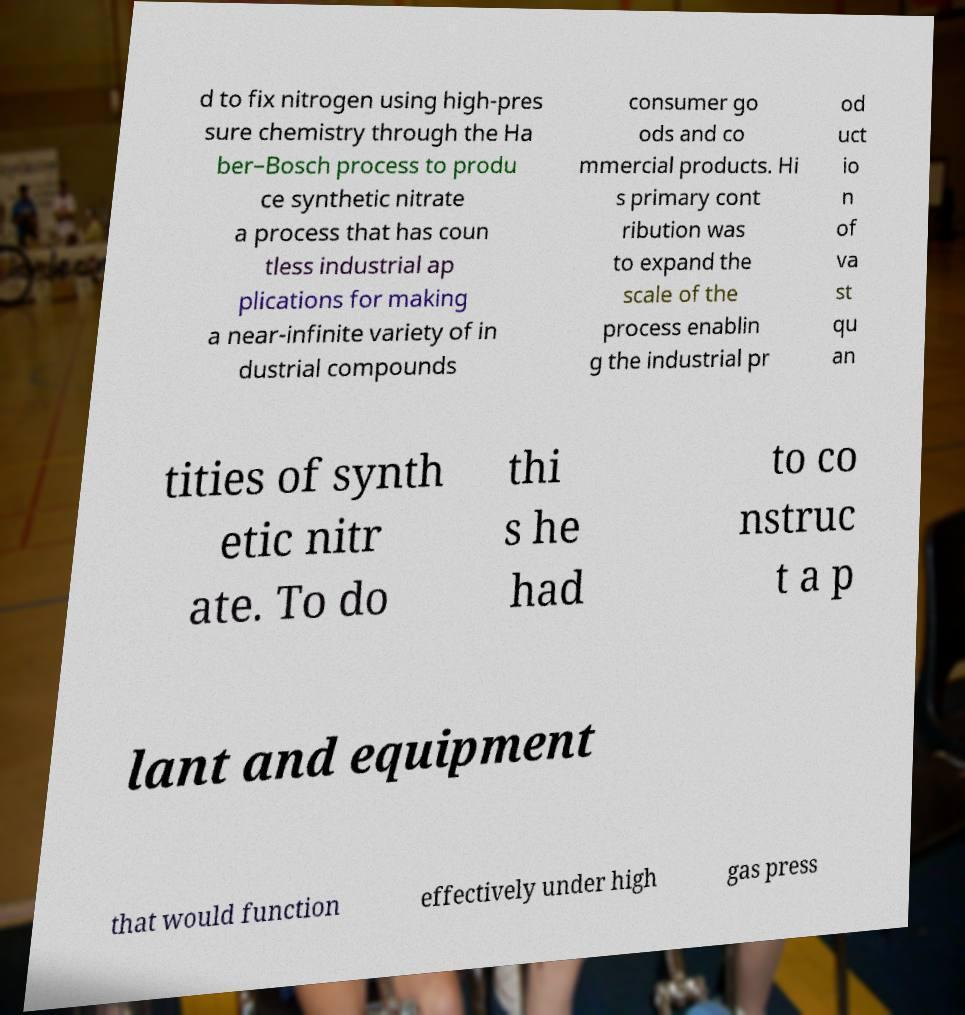Could you extract and type out the text from this image? d to fix nitrogen using high-pres sure chemistry through the Ha ber–Bosch process to produ ce synthetic nitrate a process that has coun tless industrial ap plications for making a near-infinite variety of in dustrial compounds consumer go ods and co mmercial products. Hi s primary cont ribution was to expand the scale of the process enablin g the industrial pr od uct io n of va st qu an tities of synth etic nitr ate. To do thi s he had to co nstruc t a p lant and equipment that would function effectively under high gas press 